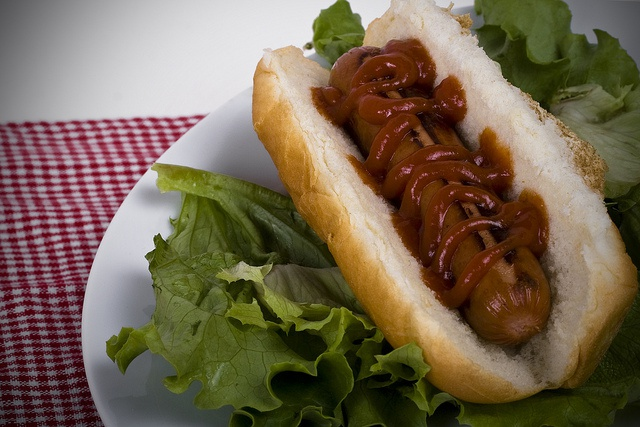Describe the objects in this image and their specific colors. I can see dining table in black, darkgreen, maroon, gray, and darkgray tones and hot dog in gray, maroon, black, darkgray, and tan tones in this image. 